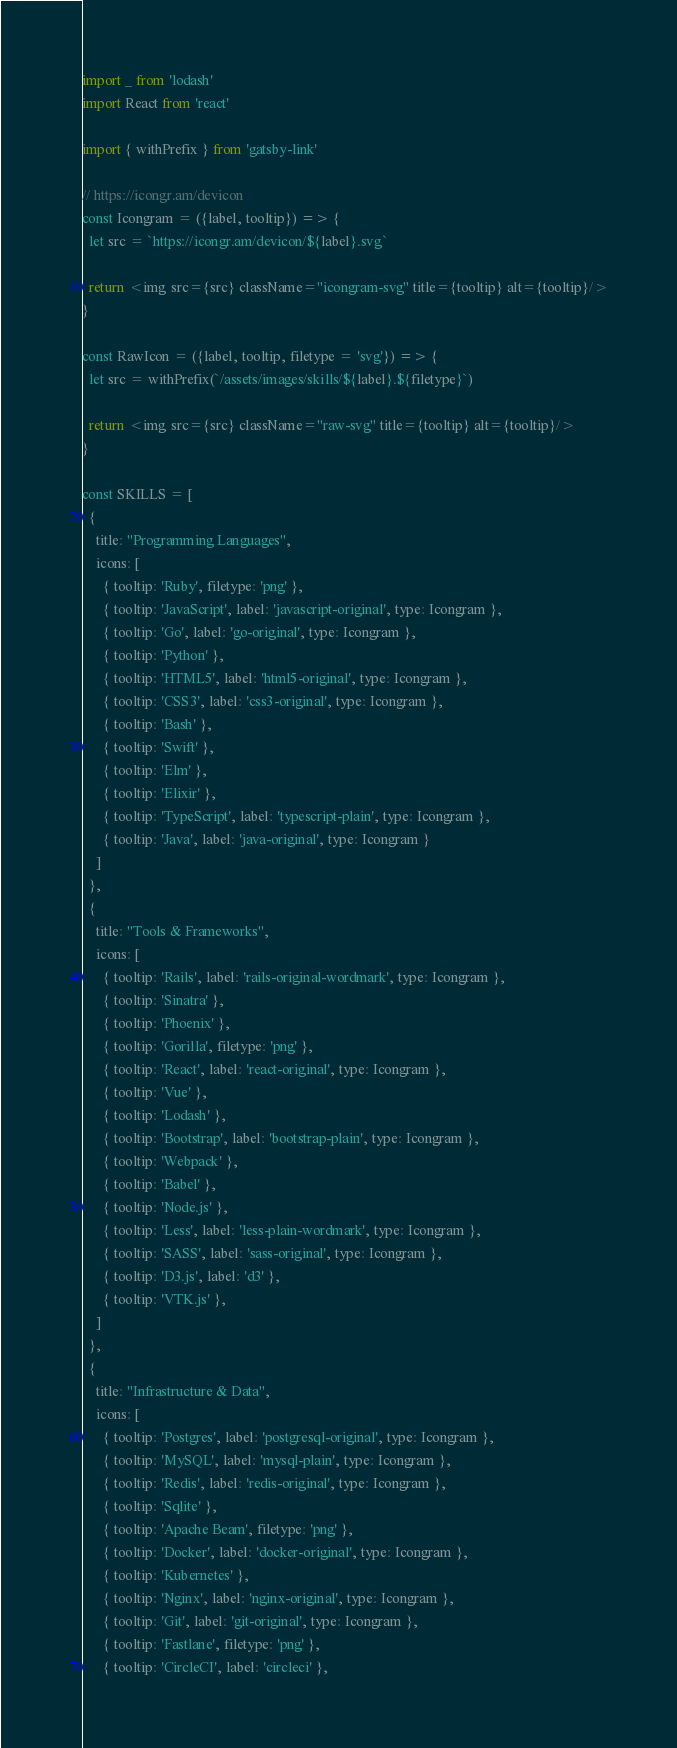Convert code to text. <code><loc_0><loc_0><loc_500><loc_500><_JavaScript_>import _ from 'lodash'
import React from 'react'

import { withPrefix } from 'gatsby-link'

// https://icongr.am/devicon
const Icongram = ({label, tooltip}) => {
  let src = `https://icongr.am/devicon/${label}.svg`

  return <img src={src} className="icongram-svg" title={tooltip} alt={tooltip}/>
}

const RawIcon = ({label, tooltip, filetype = 'svg'}) => {
  let src = withPrefix(`/assets/images/skills/${label}.${filetype}`)

  return <img src={src} className="raw-svg" title={tooltip} alt={tooltip}/>
}

const SKILLS = [
  {
    title: "Programming Languages",
    icons: [
      { tooltip: 'Ruby', filetype: 'png' },
      { tooltip: 'JavaScript', label: 'javascript-original', type: Icongram },
      { tooltip: 'Go', label: 'go-original', type: Icongram },
      { tooltip: 'Python' },
      { tooltip: 'HTML5', label: 'html5-original', type: Icongram },
      { tooltip: 'CSS3', label: 'css3-original', type: Icongram },
      { tooltip: 'Bash' },
      { tooltip: 'Swift' },
      { tooltip: 'Elm' },
      { tooltip: 'Elixir' },
      { tooltip: 'TypeScript', label: 'typescript-plain', type: Icongram },
      { tooltip: 'Java', label: 'java-original', type: Icongram }
    ]
  },
  {
    title: "Tools & Frameworks",
    icons: [
      { tooltip: 'Rails', label: 'rails-original-wordmark', type: Icongram },
      { tooltip: 'Sinatra' },
      { tooltip: 'Phoenix' },
      { tooltip: 'Gorilla', filetype: 'png' },
      { tooltip: 'React', label: 'react-original', type: Icongram },
      { tooltip: 'Vue' },
      { tooltip: 'Lodash' },
      { tooltip: 'Bootstrap', label: 'bootstrap-plain', type: Icongram },
      { tooltip: 'Webpack' },
      { tooltip: 'Babel' },
      { tooltip: 'Node.js' },
      { tooltip: 'Less', label: 'less-plain-wordmark', type: Icongram },
      { tooltip: 'SASS', label: 'sass-original', type: Icongram },
      { tooltip: 'D3.js', label: 'd3' },
      { tooltip: 'VTK.js' },
    ]
  },
  {
    title: "Infrastructure & Data",
    icons: [
      { tooltip: 'Postgres', label: 'postgresql-original', type: Icongram },
      { tooltip: 'MySQL', label: 'mysql-plain', type: Icongram },
      { tooltip: 'Redis', label: 'redis-original', type: Icongram },
      { tooltip: 'Sqlite' },
      { tooltip: 'Apache Beam', filetype: 'png' },
      { tooltip: 'Docker', label: 'docker-original', type: Icongram },
      { tooltip: 'Kubernetes' },
      { tooltip: 'Nginx', label: 'nginx-original', type: Icongram },
      { tooltip: 'Git', label: 'git-original', type: Icongram },
      { tooltip: 'Fastlane', filetype: 'png' },
      { tooltip: 'CircleCI', label: 'circleci' },</code> 